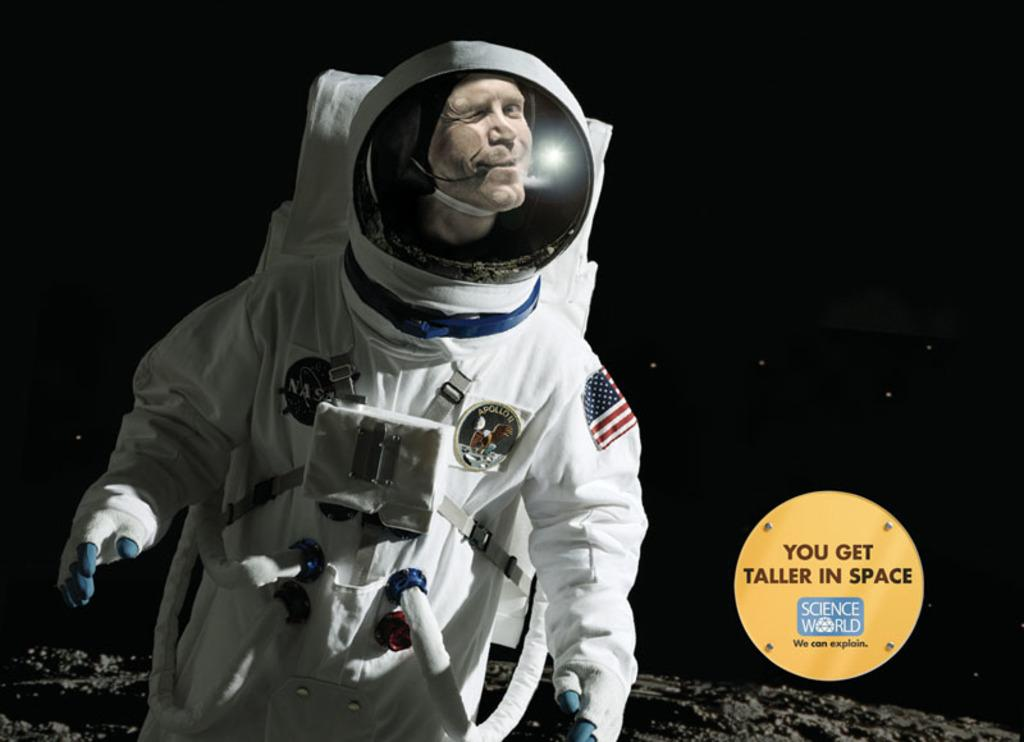What is the man in the foreground of the image wearing? The man is wearing a space suit in the foreground of the image. How would you describe the surface at the bottom of the image? The surface at the bottom of the image appears rough. Can you identify any additional features in the image? Yes, there is a watermark visible in the image. What can be said about the background of the image? The background of the image is dark. Where is the park located in the image? There is no park present in the image. What type of meeting is taking place in the image? There is no meeting depicted in the image. 